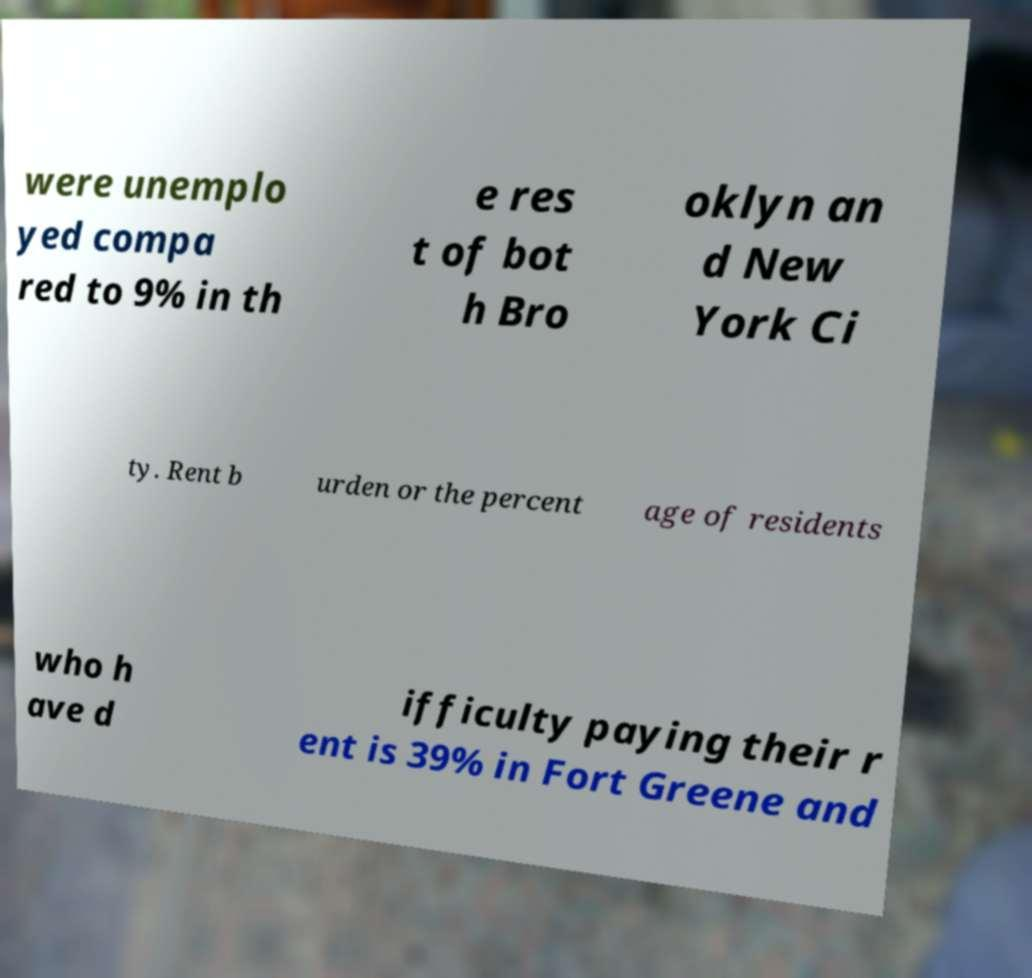Can you accurately transcribe the text from the provided image for me? were unemplo yed compa red to 9% in th e res t of bot h Bro oklyn an d New York Ci ty. Rent b urden or the percent age of residents who h ave d ifficulty paying their r ent is 39% in Fort Greene and 